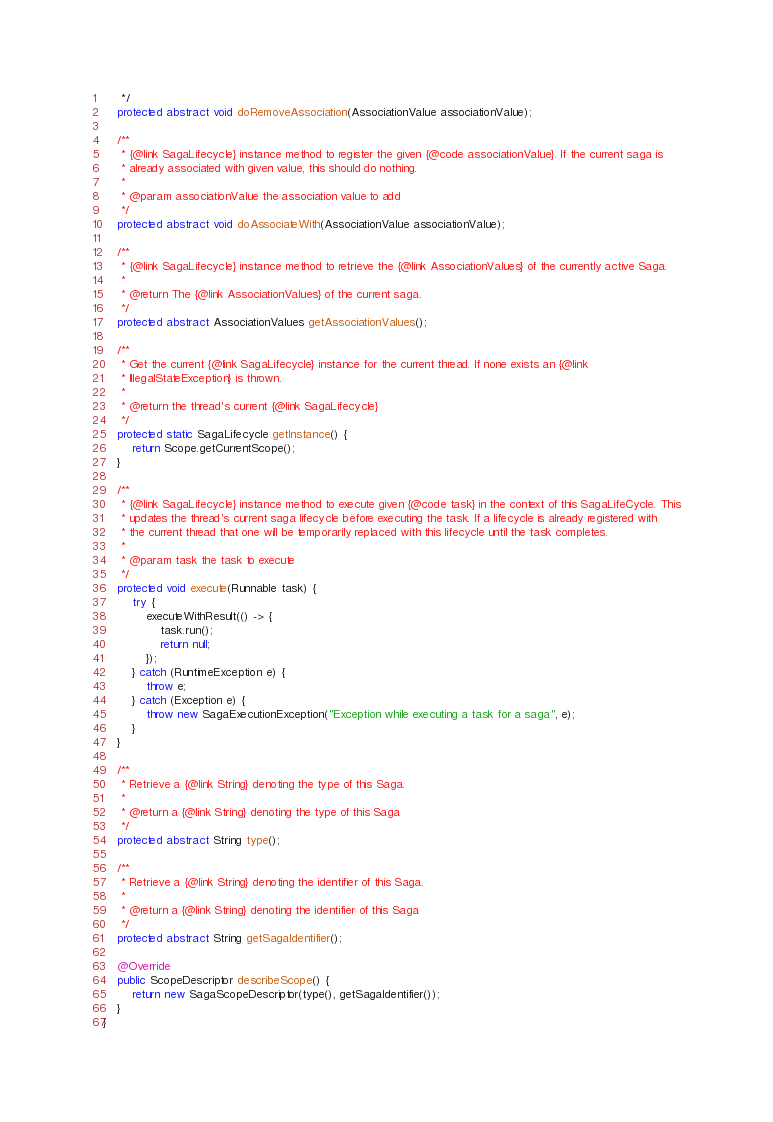<code> <loc_0><loc_0><loc_500><loc_500><_Java_>     */
    protected abstract void doRemoveAssociation(AssociationValue associationValue);

    /**
     * {@link SagaLifecycle} instance method to register the given {@code associationValue}. If the current saga is
     * already associated with given value, this should do nothing.
     *
     * @param associationValue the association value to add
     */
    protected abstract void doAssociateWith(AssociationValue associationValue);

    /**
     * {@link SagaLifecycle} instance method to retrieve the {@link AssociationValues} of the currently active Saga.
     *
     * @return The {@link AssociationValues} of the current saga.
     */
    protected abstract AssociationValues getAssociationValues();

    /**
     * Get the current {@link SagaLifecycle} instance for the current thread. If none exists an {@link
     * IllegalStateException} is thrown.
     *
     * @return the thread's current {@link SagaLifecycle}
     */
    protected static SagaLifecycle getInstance() {
        return Scope.getCurrentScope();
    }

    /**
     * {@link SagaLifecycle} instance method to execute given {@code task} in the context of this SagaLifeCycle. This
     * updates the thread's current saga lifecycle before executing the task. If a lifecycle is already registered with
     * the current thread that one will be temporarily replaced with this lifecycle until the task completes.
     *
     * @param task the task to execute
     */
    protected void execute(Runnable task) {
        try {
            executeWithResult(() -> {
                task.run();
                return null;
            });
        } catch (RuntimeException e) {
            throw e;
        } catch (Exception e) {
            throw new SagaExecutionException("Exception while executing a task for a saga", e);
        }
    }

    /**
     * Retrieve a {@link String} denoting the type of this Saga.
     *
     * @return a {@link String} denoting the type of this Saga
     */
    protected abstract String type();

    /**
     * Retrieve a {@link String} denoting the identifier of this Saga.
     *
     * @return a {@link String} denoting the identifier of this Saga
     */
    protected abstract String getSagaIdentifier();

    @Override
    public ScopeDescriptor describeScope() {
        return new SagaScopeDescriptor(type(), getSagaIdentifier());
    }
}
</code> 